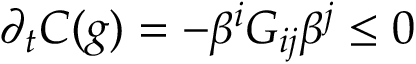Convert formula to latex. <formula><loc_0><loc_0><loc_500><loc_500>\partial _ { t } C ( g ) = - \beta ^ { i } G _ { i j } \beta ^ { j } \leq 0</formula> 